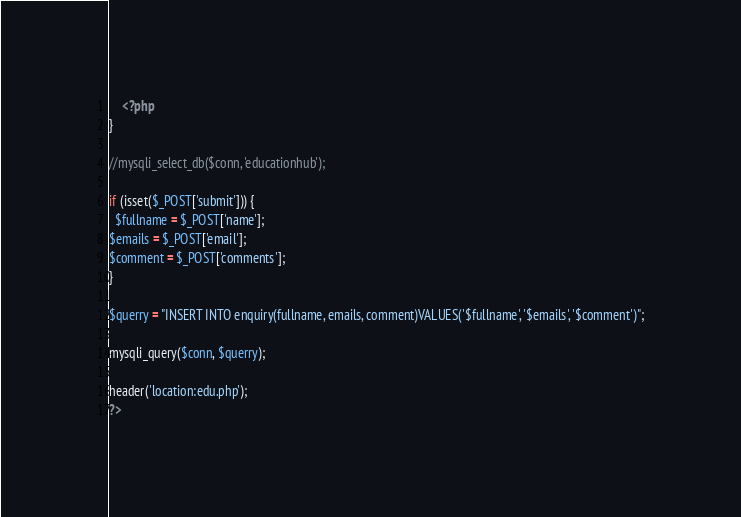Convert code to text. <code><loc_0><loc_0><loc_500><loc_500><_PHP_>    <?php
}

//mysqli_select_db($conn, 'educationhub');

if (isset($_POST['submit'])) {
  $fullname = $_POST['name'];
$emails = $_POST['email'];
$comment = $_POST['comments'];
}

$querry = "INSERT INTO enquiry(fullname, emails, comment)VALUES('$fullname', '$emails', '$comment')";

mysqli_query($conn, $querry);

header('location:edu.php');
?></code> 